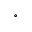<formula> <loc_0><loc_0><loc_500><loc_500>^ { \circ }</formula> 